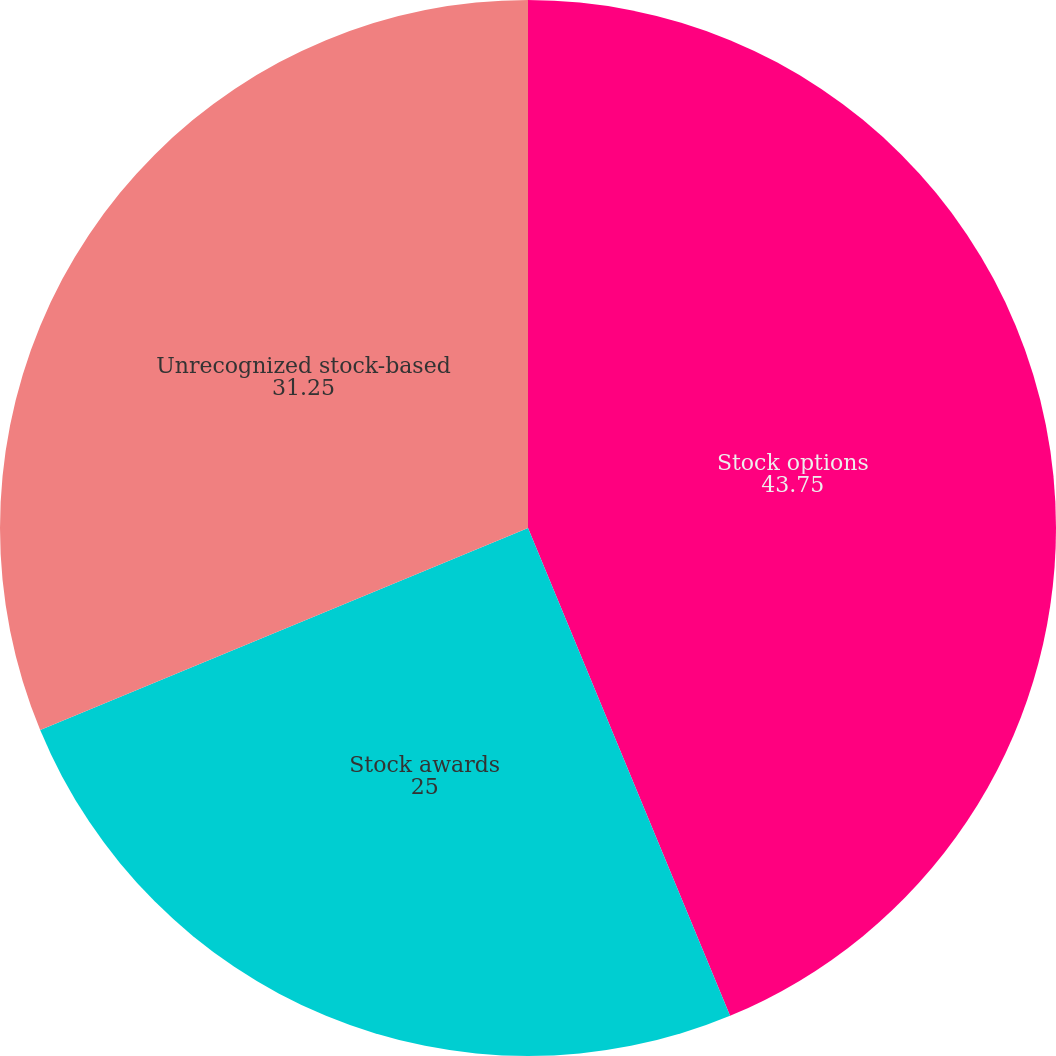Convert chart. <chart><loc_0><loc_0><loc_500><loc_500><pie_chart><fcel>Stock options<fcel>Stock awards<fcel>Unrecognized stock-based<nl><fcel>43.75%<fcel>25.0%<fcel>31.25%<nl></chart> 